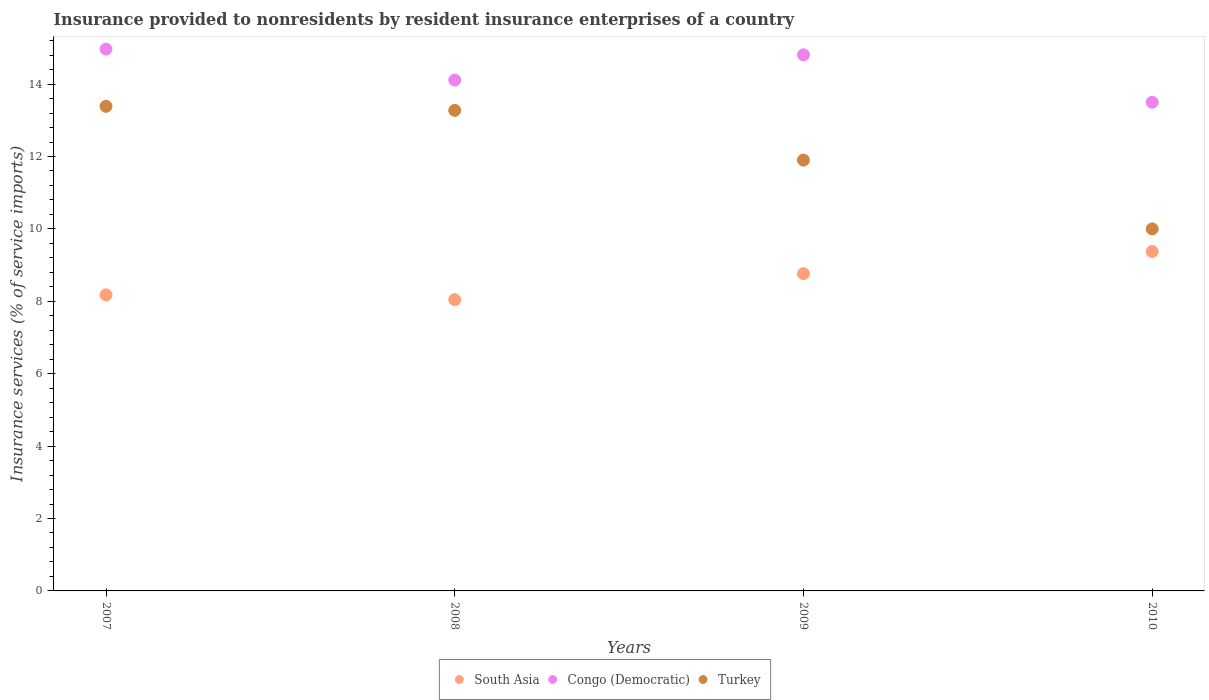Is the number of dotlines equal to the number of legend labels?
Your answer should be compact. Yes. What is the insurance provided to nonresidents in Congo (Democratic) in 2007?
Make the answer very short. 14.97. Across all years, what is the maximum insurance provided to nonresidents in Turkey?
Make the answer very short. 13.39. Across all years, what is the minimum insurance provided to nonresidents in Turkey?
Provide a succinct answer. 10. In which year was the insurance provided to nonresidents in South Asia minimum?
Offer a terse response. 2008. What is the total insurance provided to nonresidents in South Asia in the graph?
Give a very brief answer. 34.36. What is the difference between the insurance provided to nonresidents in Congo (Democratic) in 2007 and that in 2010?
Your response must be concise. 1.47. What is the difference between the insurance provided to nonresidents in South Asia in 2009 and the insurance provided to nonresidents in Congo (Democratic) in 2007?
Ensure brevity in your answer.  -6.2. What is the average insurance provided to nonresidents in Congo (Democratic) per year?
Provide a succinct answer. 14.35. In the year 2010, what is the difference between the insurance provided to nonresidents in South Asia and insurance provided to nonresidents in Turkey?
Provide a short and direct response. -0.62. In how many years, is the insurance provided to nonresidents in South Asia greater than 0.4 %?
Your response must be concise. 4. What is the ratio of the insurance provided to nonresidents in Turkey in 2008 to that in 2009?
Keep it short and to the point. 1.12. Is the insurance provided to nonresidents in Congo (Democratic) in 2008 less than that in 2009?
Your response must be concise. Yes. Is the difference between the insurance provided to nonresidents in South Asia in 2008 and 2009 greater than the difference between the insurance provided to nonresidents in Turkey in 2008 and 2009?
Give a very brief answer. No. What is the difference between the highest and the second highest insurance provided to nonresidents in Turkey?
Your answer should be compact. 0.11. What is the difference between the highest and the lowest insurance provided to nonresidents in Turkey?
Ensure brevity in your answer.  3.39. Is the sum of the insurance provided to nonresidents in South Asia in 2009 and 2010 greater than the maximum insurance provided to nonresidents in Turkey across all years?
Offer a terse response. Yes. Is it the case that in every year, the sum of the insurance provided to nonresidents in Turkey and insurance provided to nonresidents in Congo (Democratic)  is greater than the insurance provided to nonresidents in South Asia?
Make the answer very short. Yes. Is the insurance provided to nonresidents in Turkey strictly greater than the insurance provided to nonresidents in South Asia over the years?
Provide a short and direct response. Yes. How many dotlines are there?
Your response must be concise. 3. Does the graph contain any zero values?
Make the answer very short. No. Does the graph contain grids?
Offer a very short reply. No. How many legend labels are there?
Give a very brief answer. 3. What is the title of the graph?
Your answer should be compact. Insurance provided to nonresidents by resident insurance enterprises of a country. What is the label or title of the X-axis?
Give a very brief answer. Years. What is the label or title of the Y-axis?
Offer a very short reply. Insurance services (% of service imports). What is the Insurance services (% of service imports) of South Asia in 2007?
Ensure brevity in your answer.  8.18. What is the Insurance services (% of service imports) in Congo (Democratic) in 2007?
Your response must be concise. 14.97. What is the Insurance services (% of service imports) of Turkey in 2007?
Offer a very short reply. 13.39. What is the Insurance services (% of service imports) of South Asia in 2008?
Keep it short and to the point. 8.05. What is the Insurance services (% of service imports) in Congo (Democratic) in 2008?
Provide a short and direct response. 14.11. What is the Insurance services (% of service imports) in Turkey in 2008?
Your answer should be very brief. 13.27. What is the Insurance services (% of service imports) in South Asia in 2009?
Keep it short and to the point. 8.76. What is the Insurance services (% of service imports) of Congo (Democratic) in 2009?
Your answer should be very brief. 14.81. What is the Insurance services (% of service imports) of Turkey in 2009?
Your answer should be very brief. 11.9. What is the Insurance services (% of service imports) of South Asia in 2010?
Your answer should be very brief. 9.38. What is the Insurance services (% of service imports) of Congo (Democratic) in 2010?
Your answer should be very brief. 13.5. What is the Insurance services (% of service imports) of Turkey in 2010?
Offer a terse response. 10. Across all years, what is the maximum Insurance services (% of service imports) of South Asia?
Give a very brief answer. 9.38. Across all years, what is the maximum Insurance services (% of service imports) in Congo (Democratic)?
Make the answer very short. 14.97. Across all years, what is the maximum Insurance services (% of service imports) of Turkey?
Give a very brief answer. 13.39. Across all years, what is the minimum Insurance services (% of service imports) of South Asia?
Your answer should be compact. 8.05. Across all years, what is the minimum Insurance services (% of service imports) in Congo (Democratic)?
Offer a very short reply. 13.5. Across all years, what is the minimum Insurance services (% of service imports) in Turkey?
Give a very brief answer. 10. What is the total Insurance services (% of service imports) in South Asia in the graph?
Offer a very short reply. 34.36. What is the total Insurance services (% of service imports) in Congo (Democratic) in the graph?
Your answer should be very brief. 57.39. What is the total Insurance services (% of service imports) of Turkey in the graph?
Your answer should be compact. 48.56. What is the difference between the Insurance services (% of service imports) in South Asia in 2007 and that in 2008?
Your answer should be very brief. 0.13. What is the difference between the Insurance services (% of service imports) in Congo (Democratic) in 2007 and that in 2008?
Provide a succinct answer. 0.85. What is the difference between the Insurance services (% of service imports) of Turkey in 2007 and that in 2008?
Provide a short and direct response. 0.11. What is the difference between the Insurance services (% of service imports) of South Asia in 2007 and that in 2009?
Your answer should be compact. -0.59. What is the difference between the Insurance services (% of service imports) in Congo (Democratic) in 2007 and that in 2009?
Give a very brief answer. 0.16. What is the difference between the Insurance services (% of service imports) of Turkey in 2007 and that in 2009?
Your answer should be very brief. 1.49. What is the difference between the Insurance services (% of service imports) in South Asia in 2007 and that in 2010?
Offer a very short reply. -1.2. What is the difference between the Insurance services (% of service imports) of Congo (Democratic) in 2007 and that in 2010?
Your response must be concise. 1.47. What is the difference between the Insurance services (% of service imports) in Turkey in 2007 and that in 2010?
Your response must be concise. 3.39. What is the difference between the Insurance services (% of service imports) of South Asia in 2008 and that in 2009?
Your answer should be very brief. -0.72. What is the difference between the Insurance services (% of service imports) of Congo (Democratic) in 2008 and that in 2009?
Keep it short and to the point. -0.7. What is the difference between the Insurance services (% of service imports) in Turkey in 2008 and that in 2009?
Provide a short and direct response. 1.37. What is the difference between the Insurance services (% of service imports) in South Asia in 2008 and that in 2010?
Your answer should be very brief. -1.33. What is the difference between the Insurance services (% of service imports) in Congo (Democratic) in 2008 and that in 2010?
Your answer should be very brief. 0.61. What is the difference between the Insurance services (% of service imports) in Turkey in 2008 and that in 2010?
Ensure brevity in your answer.  3.27. What is the difference between the Insurance services (% of service imports) in South Asia in 2009 and that in 2010?
Your response must be concise. -0.61. What is the difference between the Insurance services (% of service imports) in Congo (Democratic) in 2009 and that in 2010?
Offer a very short reply. 1.31. What is the difference between the Insurance services (% of service imports) in Turkey in 2009 and that in 2010?
Your answer should be very brief. 1.9. What is the difference between the Insurance services (% of service imports) in South Asia in 2007 and the Insurance services (% of service imports) in Congo (Democratic) in 2008?
Your response must be concise. -5.93. What is the difference between the Insurance services (% of service imports) in South Asia in 2007 and the Insurance services (% of service imports) in Turkey in 2008?
Your answer should be very brief. -5.1. What is the difference between the Insurance services (% of service imports) in Congo (Democratic) in 2007 and the Insurance services (% of service imports) in Turkey in 2008?
Your answer should be compact. 1.69. What is the difference between the Insurance services (% of service imports) of South Asia in 2007 and the Insurance services (% of service imports) of Congo (Democratic) in 2009?
Your answer should be compact. -6.63. What is the difference between the Insurance services (% of service imports) in South Asia in 2007 and the Insurance services (% of service imports) in Turkey in 2009?
Your response must be concise. -3.72. What is the difference between the Insurance services (% of service imports) of Congo (Democratic) in 2007 and the Insurance services (% of service imports) of Turkey in 2009?
Your response must be concise. 3.07. What is the difference between the Insurance services (% of service imports) in South Asia in 2007 and the Insurance services (% of service imports) in Congo (Democratic) in 2010?
Ensure brevity in your answer.  -5.32. What is the difference between the Insurance services (% of service imports) of South Asia in 2007 and the Insurance services (% of service imports) of Turkey in 2010?
Ensure brevity in your answer.  -1.82. What is the difference between the Insurance services (% of service imports) of Congo (Democratic) in 2007 and the Insurance services (% of service imports) of Turkey in 2010?
Your response must be concise. 4.97. What is the difference between the Insurance services (% of service imports) in South Asia in 2008 and the Insurance services (% of service imports) in Congo (Democratic) in 2009?
Your response must be concise. -6.76. What is the difference between the Insurance services (% of service imports) in South Asia in 2008 and the Insurance services (% of service imports) in Turkey in 2009?
Keep it short and to the point. -3.85. What is the difference between the Insurance services (% of service imports) in Congo (Democratic) in 2008 and the Insurance services (% of service imports) in Turkey in 2009?
Offer a terse response. 2.21. What is the difference between the Insurance services (% of service imports) of South Asia in 2008 and the Insurance services (% of service imports) of Congo (Democratic) in 2010?
Your answer should be very brief. -5.45. What is the difference between the Insurance services (% of service imports) in South Asia in 2008 and the Insurance services (% of service imports) in Turkey in 2010?
Your response must be concise. -1.96. What is the difference between the Insurance services (% of service imports) of Congo (Democratic) in 2008 and the Insurance services (% of service imports) of Turkey in 2010?
Provide a succinct answer. 4.11. What is the difference between the Insurance services (% of service imports) of South Asia in 2009 and the Insurance services (% of service imports) of Congo (Democratic) in 2010?
Ensure brevity in your answer.  -4.73. What is the difference between the Insurance services (% of service imports) in South Asia in 2009 and the Insurance services (% of service imports) in Turkey in 2010?
Give a very brief answer. -1.24. What is the difference between the Insurance services (% of service imports) of Congo (Democratic) in 2009 and the Insurance services (% of service imports) of Turkey in 2010?
Make the answer very short. 4.81. What is the average Insurance services (% of service imports) in South Asia per year?
Offer a terse response. 8.59. What is the average Insurance services (% of service imports) in Congo (Democratic) per year?
Your answer should be compact. 14.35. What is the average Insurance services (% of service imports) in Turkey per year?
Offer a very short reply. 12.14. In the year 2007, what is the difference between the Insurance services (% of service imports) in South Asia and Insurance services (% of service imports) in Congo (Democratic)?
Provide a succinct answer. -6.79. In the year 2007, what is the difference between the Insurance services (% of service imports) in South Asia and Insurance services (% of service imports) in Turkey?
Ensure brevity in your answer.  -5.21. In the year 2007, what is the difference between the Insurance services (% of service imports) in Congo (Democratic) and Insurance services (% of service imports) in Turkey?
Make the answer very short. 1.58. In the year 2008, what is the difference between the Insurance services (% of service imports) in South Asia and Insurance services (% of service imports) in Congo (Democratic)?
Keep it short and to the point. -6.07. In the year 2008, what is the difference between the Insurance services (% of service imports) in South Asia and Insurance services (% of service imports) in Turkey?
Your answer should be very brief. -5.23. In the year 2008, what is the difference between the Insurance services (% of service imports) in Congo (Democratic) and Insurance services (% of service imports) in Turkey?
Offer a very short reply. 0.84. In the year 2009, what is the difference between the Insurance services (% of service imports) in South Asia and Insurance services (% of service imports) in Congo (Democratic)?
Provide a short and direct response. -6.05. In the year 2009, what is the difference between the Insurance services (% of service imports) in South Asia and Insurance services (% of service imports) in Turkey?
Give a very brief answer. -3.14. In the year 2009, what is the difference between the Insurance services (% of service imports) in Congo (Democratic) and Insurance services (% of service imports) in Turkey?
Offer a very short reply. 2.91. In the year 2010, what is the difference between the Insurance services (% of service imports) in South Asia and Insurance services (% of service imports) in Congo (Democratic)?
Keep it short and to the point. -4.12. In the year 2010, what is the difference between the Insurance services (% of service imports) of South Asia and Insurance services (% of service imports) of Turkey?
Keep it short and to the point. -0.62. In the year 2010, what is the difference between the Insurance services (% of service imports) of Congo (Democratic) and Insurance services (% of service imports) of Turkey?
Provide a short and direct response. 3.5. What is the ratio of the Insurance services (% of service imports) in South Asia in 2007 to that in 2008?
Ensure brevity in your answer.  1.02. What is the ratio of the Insurance services (% of service imports) of Congo (Democratic) in 2007 to that in 2008?
Provide a short and direct response. 1.06. What is the ratio of the Insurance services (% of service imports) in Turkey in 2007 to that in 2008?
Ensure brevity in your answer.  1.01. What is the ratio of the Insurance services (% of service imports) of South Asia in 2007 to that in 2009?
Offer a very short reply. 0.93. What is the ratio of the Insurance services (% of service imports) of Congo (Democratic) in 2007 to that in 2009?
Give a very brief answer. 1.01. What is the ratio of the Insurance services (% of service imports) in Turkey in 2007 to that in 2009?
Your response must be concise. 1.12. What is the ratio of the Insurance services (% of service imports) in South Asia in 2007 to that in 2010?
Your response must be concise. 0.87. What is the ratio of the Insurance services (% of service imports) in Congo (Democratic) in 2007 to that in 2010?
Your response must be concise. 1.11. What is the ratio of the Insurance services (% of service imports) in Turkey in 2007 to that in 2010?
Give a very brief answer. 1.34. What is the ratio of the Insurance services (% of service imports) in South Asia in 2008 to that in 2009?
Your answer should be compact. 0.92. What is the ratio of the Insurance services (% of service imports) in Congo (Democratic) in 2008 to that in 2009?
Offer a very short reply. 0.95. What is the ratio of the Insurance services (% of service imports) of Turkey in 2008 to that in 2009?
Keep it short and to the point. 1.12. What is the ratio of the Insurance services (% of service imports) in South Asia in 2008 to that in 2010?
Your response must be concise. 0.86. What is the ratio of the Insurance services (% of service imports) of Congo (Democratic) in 2008 to that in 2010?
Your answer should be compact. 1.05. What is the ratio of the Insurance services (% of service imports) of Turkey in 2008 to that in 2010?
Your answer should be compact. 1.33. What is the ratio of the Insurance services (% of service imports) in South Asia in 2009 to that in 2010?
Offer a terse response. 0.93. What is the ratio of the Insurance services (% of service imports) of Congo (Democratic) in 2009 to that in 2010?
Keep it short and to the point. 1.1. What is the ratio of the Insurance services (% of service imports) of Turkey in 2009 to that in 2010?
Keep it short and to the point. 1.19. What is the difference between the highest and the second highest Insurance services (% of service imports) in South Asia?
Offer a very short reply. 0.61. What is the difference between the highest and the second highest Insurance services (% of service imports) in Congo (Democratic)?
Your response must be concise. 0.16. What is the difference between the highest and the second highest Insurance services (% of service imports) in Turkey?
Your answer should be compact. 0.11. What is the difference between the highest and the lowest Insurance services (% of service imports) in South Asia?
Offer a terse response. 1.33. What is the difference between the highest and the lowest Insurance services (% of service imports) of Congo (Democratic)?
Provide a short and direct response. 1.47. What is the difference between the highest and the lowest Insurance services (% of service imports) of Turkey?
Provide a short and direct response. 3.39. 